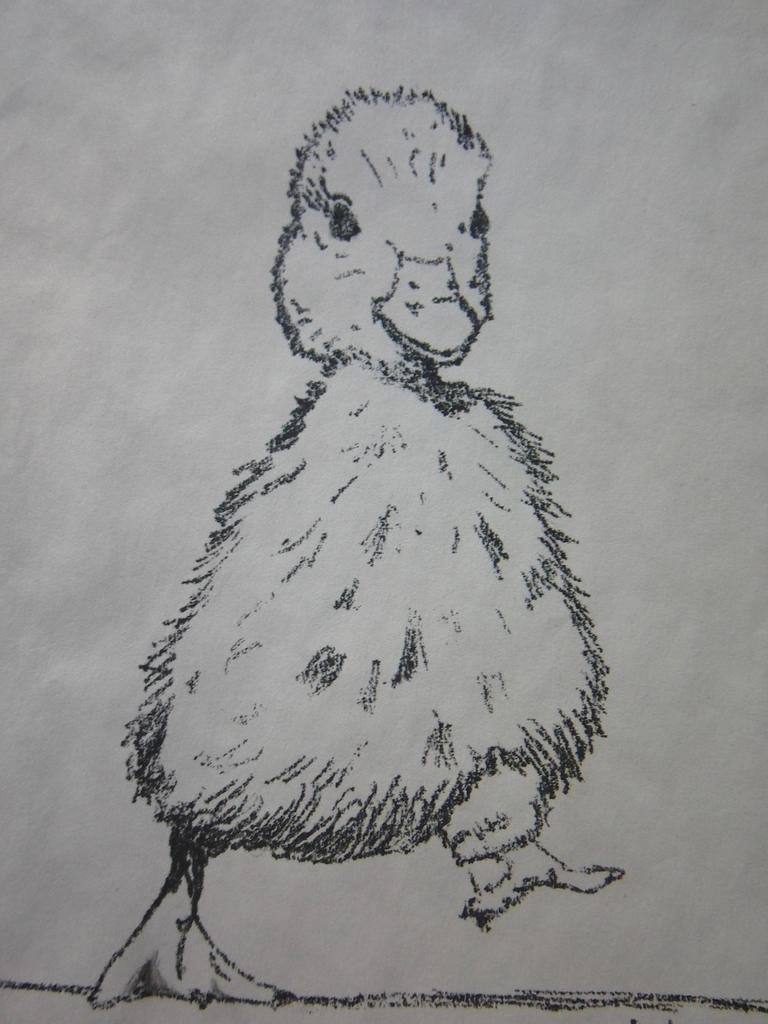What is depicted in the image? There is a drawing of an animal in the image. What is the background of the drawing? The drawing is on white paper. What type of insect can be seen climbing the hill in the image? There is no insect or hill present in the image; it features a drawing of an animal on white paper. 